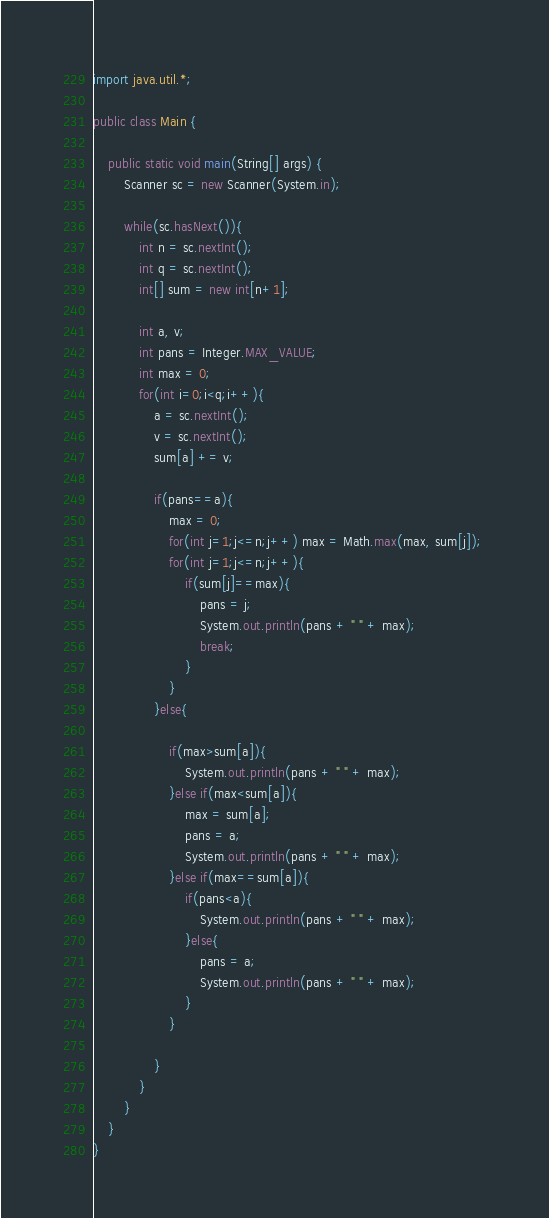<code> <loc_0><loc_0><loc_500><loc_500><_Java_>import java.util.*;

public class Main {
	
	public static void main(String[] args) {
		Scanner sc = new Scanner(System.in);
		
		while(sc.hasNext()){
			int n = sc.nextInt();
			int q = sc.nextInt();
			int[] sum = new int[n+1];	
			
			int a, v;
			int pans = Integer.MAX_VALUE;
			int max = 0;
			for(int i=0;i<q;i++){
				a = sc.nextInt();
				v = sc.nextInt();
				sum[a] += v;
				
				if(pans==a){
					max = 0;
					for(int j=1;j<=n;j++) max = Math.max(max, sum[j]); 
	                for(int j=1;j<=n;j++){
	                    if(sum[j]==max){
	                    	pans = j;
	                        System.out.println(pans + " " + max);
	                        break;
	                    }
	                }	
				}else{
				
					if(max>sum[a]){
						System.out.println(pans + " " + max);
					}else if(max<sum[a]){
						max = sum[a];
						pans = a;
						System.out.println(pans + " " + max);
					}else if(max==sum[a]){
						if(pans<a){
							System.out.println(pans + " " + max);
						}else{
							pans = a;
							System.out.println(pans + " " + max);
						}
					}
					
				}
			}
		}
	}	
}</code> 